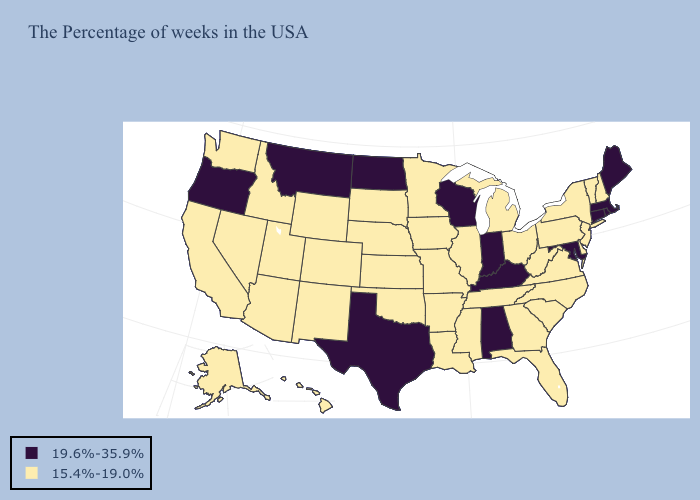Does the first symbol in the legend represent the smallest category?
Quick response, please. No. What is the value of Hawaii?
Write a very short answer. 15.4%-19.0%. What is the lowest value in states that border Delaware?
Quick response, please. 15.4%-19.0%. Name the states that have a value in the range 15.4%-19.0%?
Write a very short answer. New Hampshire, Vermont, New York, New Jersey, Delaware, Pennsylvania, Virginia, North Carolina, South Carolina, West Virginia, Ohio, Florida, Georgia, Michigan, Tennessee, Illinois, Mississippi, Louisiana, Missouri, Arkansas, Minnesota, Iowa, Kansas, Nebraska, Oklahoma, South Dakota, Wyoming, Colorado, New Mexico, Utah, Arizona, Idaho, Nevada, California, Washington, Alaska, Hawaii. Among the states that border Georgia , does Alabama have the highest value?
Quick response, please. Yes. What is the lowest value in the USA?
Concise answer only. 15.4%-19.0%. Name the states that have a value in the range 15.4%-19.0%?
Concise answer only. New Hampshire, Vermont, New York, New Jersey, Delaware, Pennsylvania, Virginia, North Carolina, South Carolina, West Virginia, Ohio, Florida, Georgia, Michigan, Tennessee, Illinois, Mississippi, Louisiana, Missouri, Arkansas, Minnesota, Iowa, Kansas, Nebraska, Oklahoma, South Dakota, Wyoming, Colorado, New Mexico, Utah, Arizona, Idaho, Nevada, California, Washington, Alaska, Hawaii. Name the states that have a value in the range 19.6%-35.9%?
Write a very short answer. Maine, Massachusetts, Rhode Island, Connecticut, Maryland, Kentucky, Indiana, Alabama, Wisconsin, Texas, North Dakota, Montana, Oregon. Among the states that border Tennessee , does Arkansas have the lowest value?
Keep it brief. Yes. What is the value of Kansas?
Short answer required. 15.4%-19.0%. Does the map have missing data?
Give a very brief answer. No. Does Texas have the highest value in the USA?
Concise answer only. Yes. What is the value of Massachusetts?
Quick response, please. 19.6%-35.9%. Is the legend a continuous bar?
Answer briefly. No. Does Montana have the lowest value in the USA?
Keep it brief. No. 